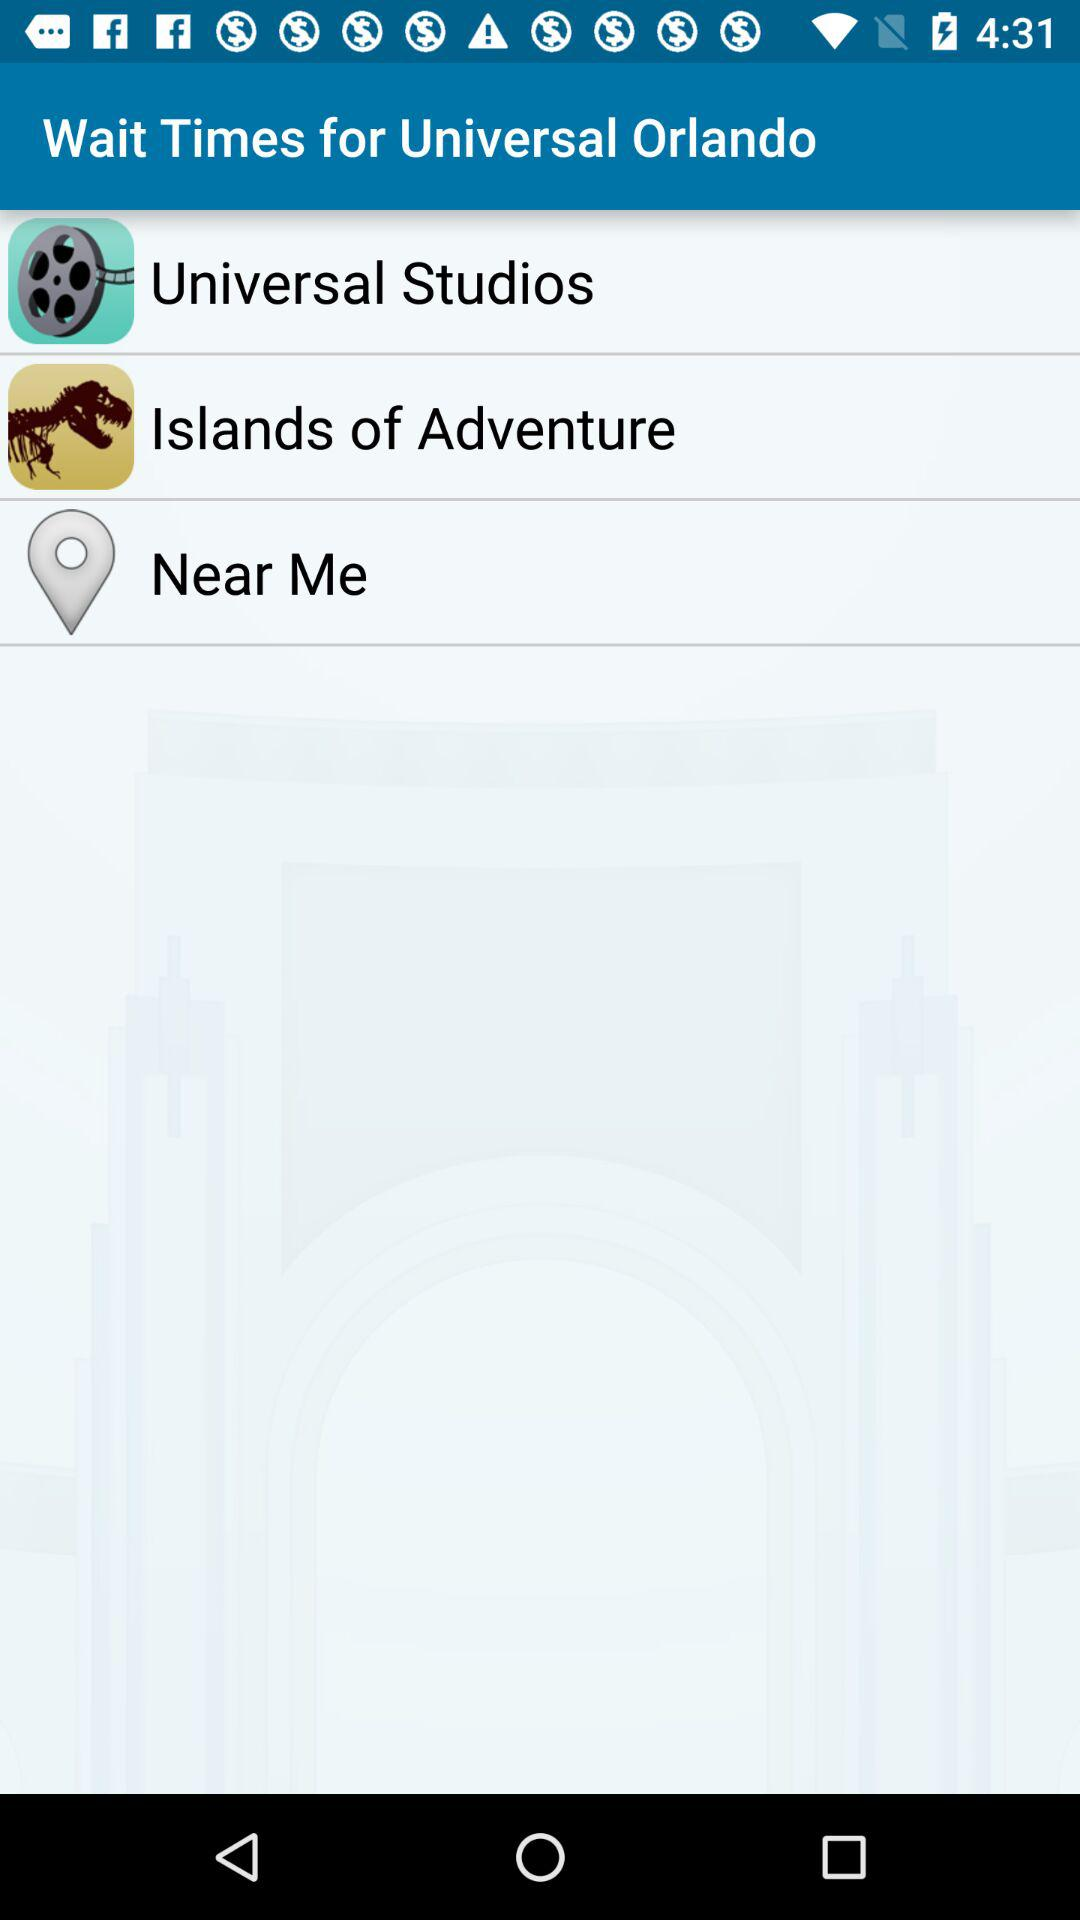What is the application name? The application name is "Wait Times for Universal Orlando". 